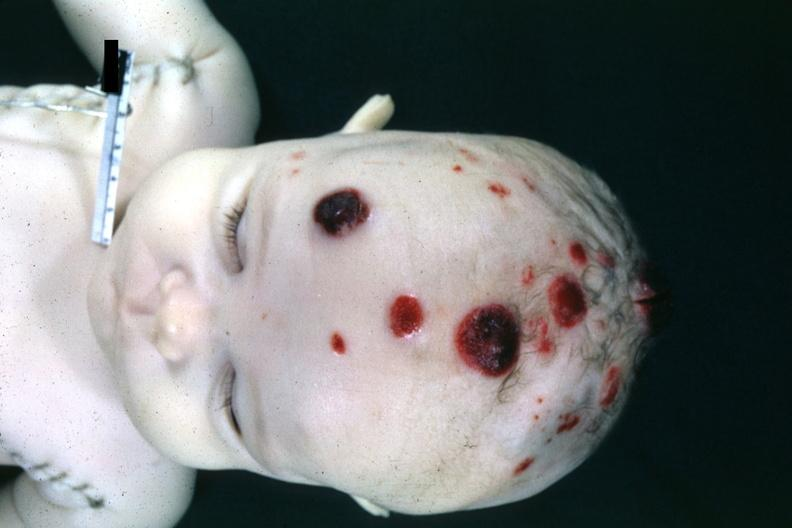what does this image show?
Answer the question using a single word or phrase. Photo of head postmorthemorrhagic appearing skin nodules are lymphoma infiltrates 4 month old child several slides from case are in file 